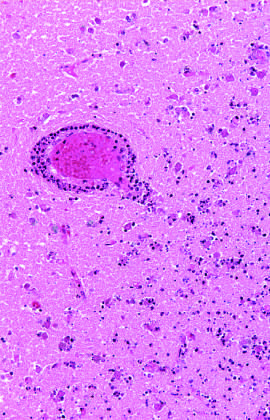what begins at the edges of the lesion, where the vascular supply is intact?
Answer the question using a single word or phrase. Infiltration of a cerebral infarction by neutrophils 